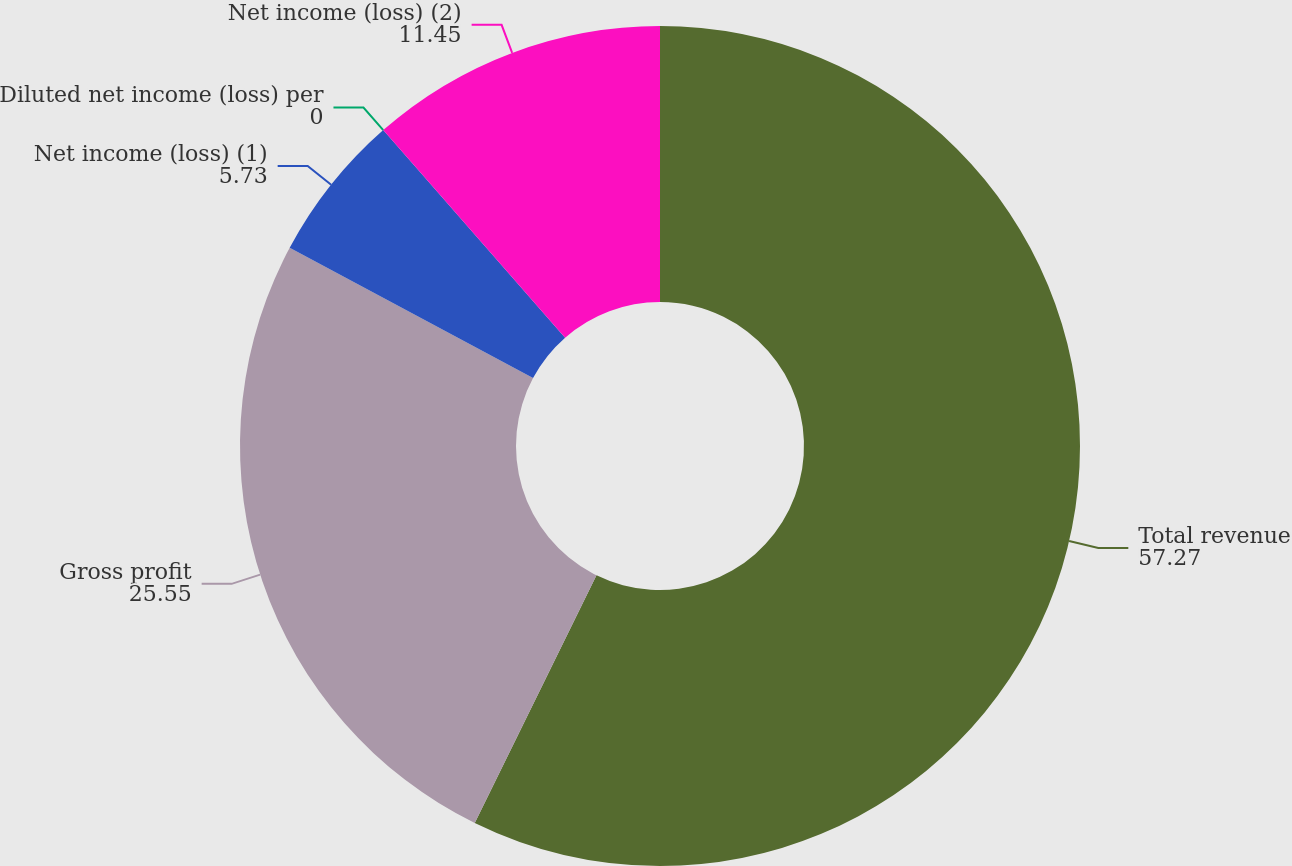Convert chart. <chart><loc_0><loc_0><loc_500><loc_500><pie_chart><fcel>Total revenue<fcel>Gross profit<fcel>Net income (loss) (1)<fcel>Diluted net income (loss) per<fcel>Net income (loss) (2)<nl><fcel>57.27%<fcel>25.55%<fcel>5.73%<fcel>0.0%<fcel>11.45%<nl></chart> 